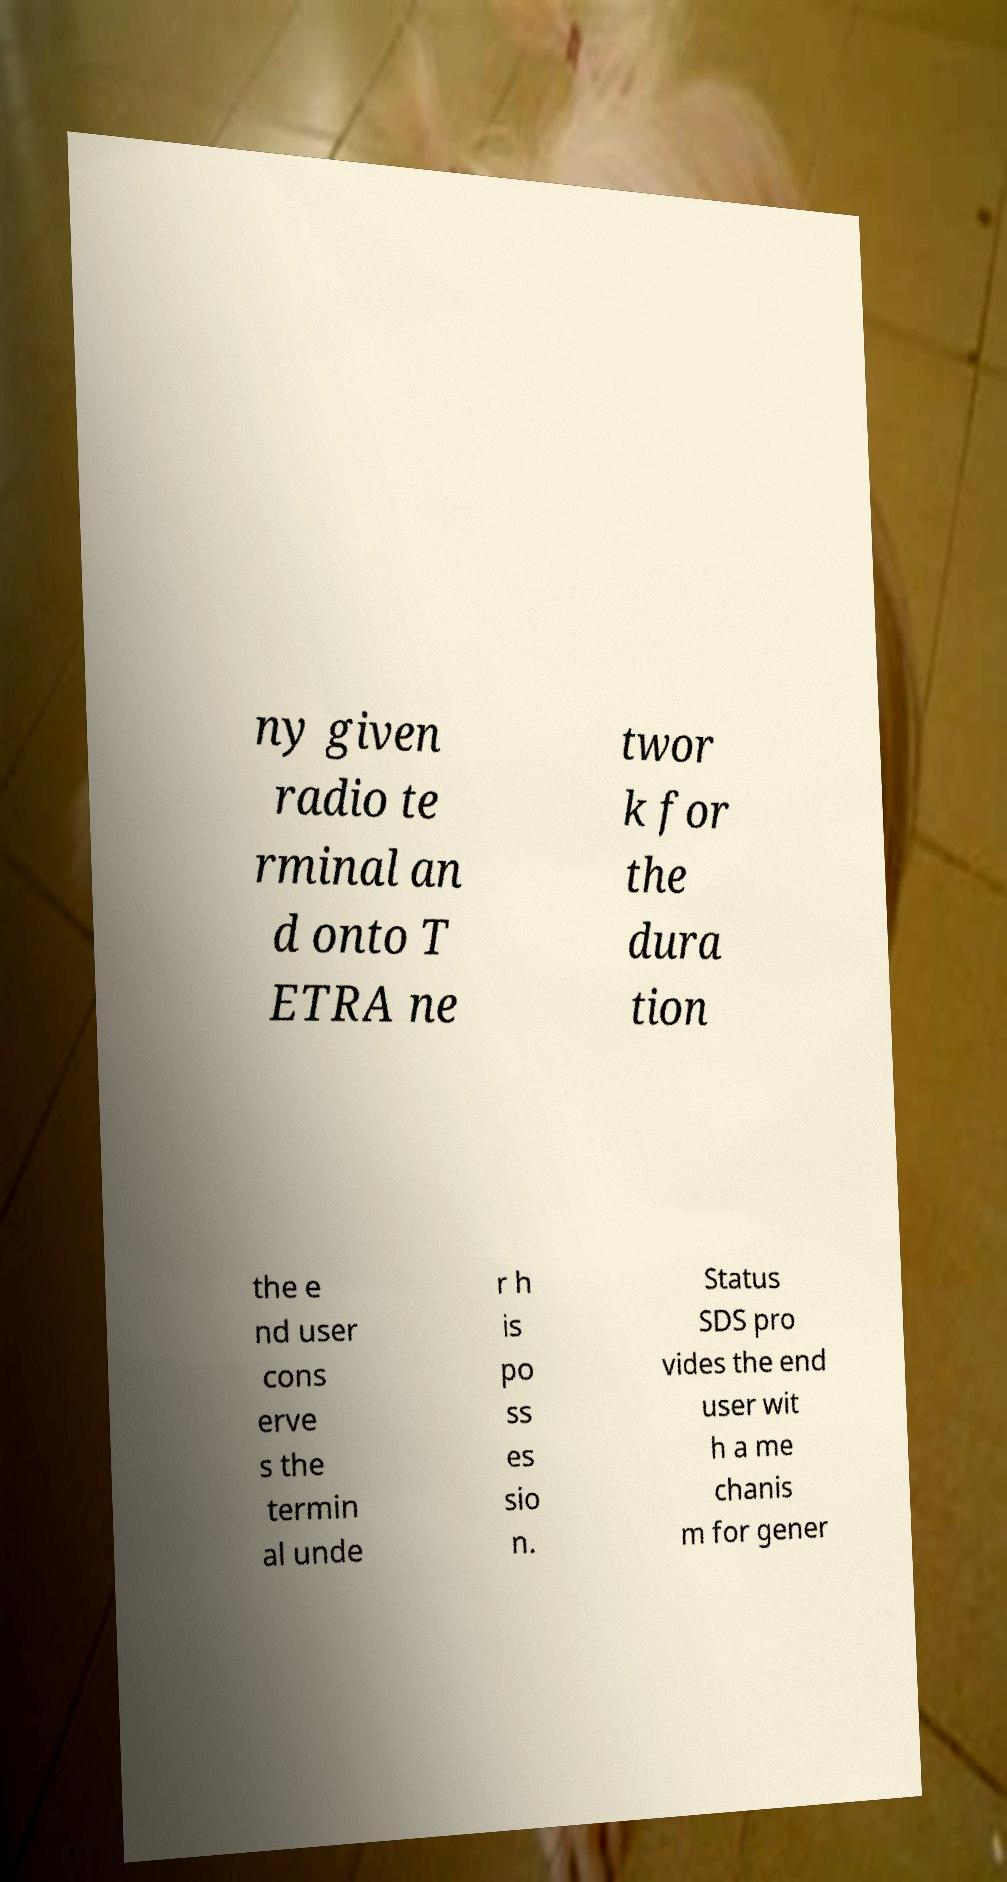Could you extract and type out the text from this image? ny given radio te rminal an d onto T ETRA ne twor k for the dura tion the e nd user cons erve s the termin al unde r h is po ss es sio n. Status SDS pro vides the end user wit h a me chanis m for gener 